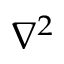Convert formula to latex. <formula><loc_0><loc_0><loc_500><loc_500>\nabla ^ { 2 }</formula> 